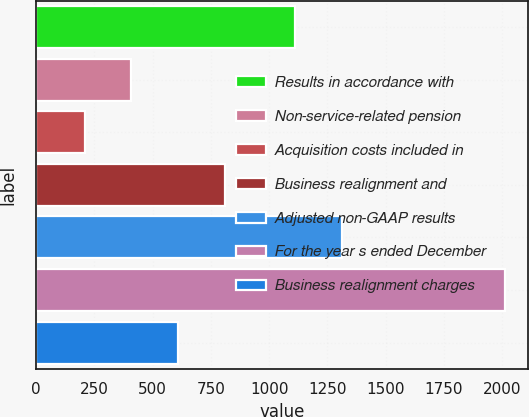Convert chart to OTSL. <chart><loc_0><loc_0><loc_500><loc_500><bar_chart><fcel>Results in accordance with<fcel>Non-service-related pension<fcel>Acquisition costs included in<fcel>Business realignment and<fcel>Adjusted non-GAAP results<fcel>For the year s ended December<fcel>Business realignment charges<nl><fcel>1111.1<fcel>408.88<fcel>208.74<fcel>809.16<fcel>1311.24<fcel>2010<fcel>609.02<nl></chart> 